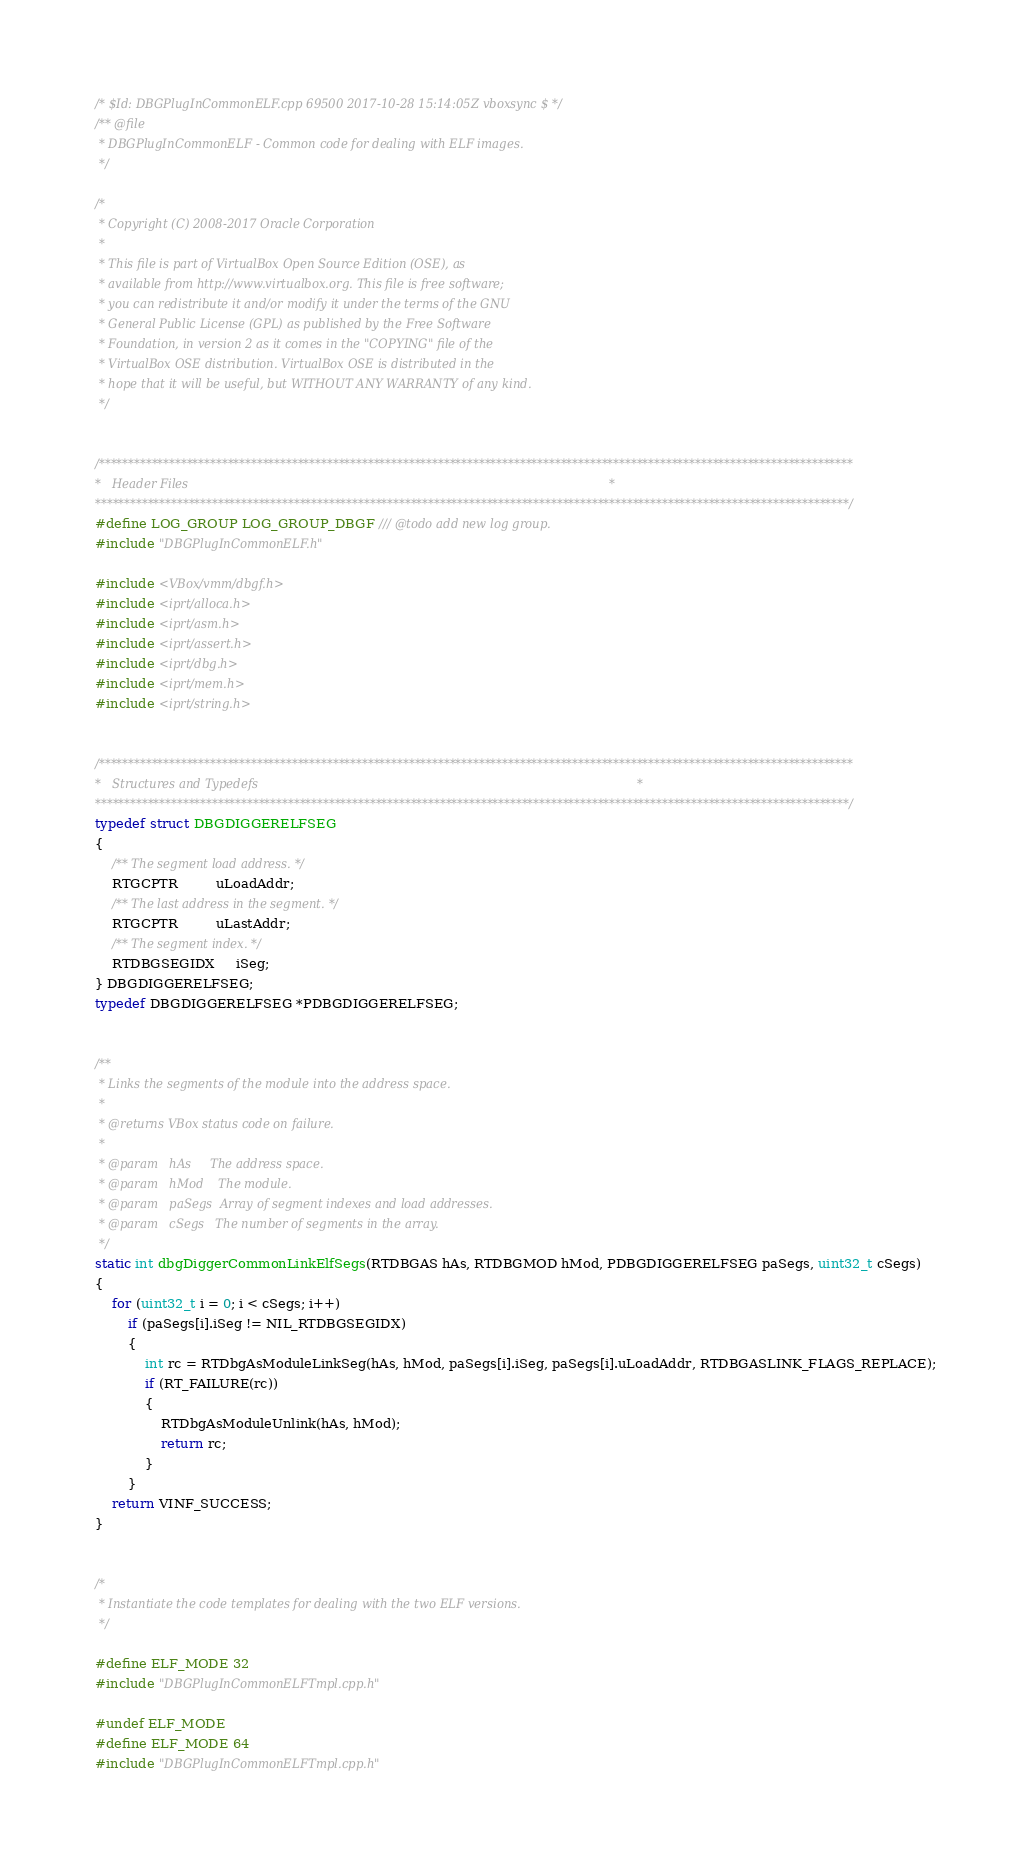<code> <loc_0><loc_0><loc_500><loc_500><_C++_>/* $Id: DBGPlugInCommonELF.cpp 69500 2017-10-28 15:14:05Z vboxsync $ */
/** @file
 * DBGPlugInCommonELF - Common code for dealing with ELF images.
 */

/*
 * Copyright (C) 2008-2017 Oracle Corporation
 *
 * This file is part of VirtualBox Open Source Edition (OSE), as
 * available from http://www.virtualbox.org. This file is free software;
 * you can redistribute it and/or modify it under the terms of the GNU
 * General Public License (GPL) as published by the Free Software
 * Foundation, in version 2 as it comes in the "COPYING" file of the
 * VirtualBox OSE distribution. VirtualBox OSE is distributed in the
 * hope that it will be useful, but WITHOUT ANY WARRANTY of any kind.
 */


/*********************************************************************************************************************************
*   Header Files                                                                                                                 *
*********************************************************************************************************************************/
#define LOG_GROUP LOG_GROUP_DBGF /// @todo add new log group.
#include "DBGPlugInCommonELF.h"

#include <VBox/vmm/dbgf.h>
#include <iprt/alloca.h>
#include <iprt/asm.h>
#include <iprt/assert.h>
#include <iprt/dbg.h>
#include <iprt/mem.h>
#include <iprt/string.h>


/*********************************************************************************************************************************
*   Structures and Typedefs                                                                                                      *
*********************************************************************************************************************************/
typedef struct DBGDIGGERELFSEG
{
    /** The segment load address. */
    RTGCPTR         uLoadAddr;
    /** The last address in the segment. */
    RTGCPTR         uLastAddr;
    /** The segment index. */
    RTDBGSEGIDX     iSeg;
} DBGDIGGERELFSEG;
typedef DBGDIGGERELFSEG *PDBGDIGGERELFSEG;


/**
 * Links the segments of the module into the address space.
 *
 * @returns VBox status code on failure.
 *
 * @param   hAs     The address space.
 * @param   hMod    The module.
 * @param   paSegs  Array of segment indexes and load addresses.
 * @param   cSegs   The number of segments in the array.
 */
static int dbgDiggerCommonLinkElfSegs(RTDBGAS hAs, RTDBGMOD hMod, PDBGDIGGERELFSEG paSegs, uint32_t cSegs)
{
    for (uint32_t i = 0; i < cSegs; i++)
        if (paSegs[i].iSeg != NIL_RTDBGSEGIDX)
        {
            int rc = RTDbgAsModuleLinkSeg(hAs, hMod, paSegs[i].iSeg, paSegs[i].uLoadAddr, RTDBGASLINK_FLAGS_REPLACE);
            if (RT_FAILURE(rc))
            {
                RTDbgAsModuleUnlink(hAs, hMod);
                return rc;
            }
        }
    return VINF_SUCCESS;
}


/*
 * Instantiate the code templates for dealing with the two ELF versions.
 */

#define ELF_MODE 32
#include "DBGPlugInCommonELFTmpl.cpp.h"

#undef ELF_MODE
#define ELF_MODE 64
#include "DBGPlugInCommonELFTmpl.cpp.h"

</code> 